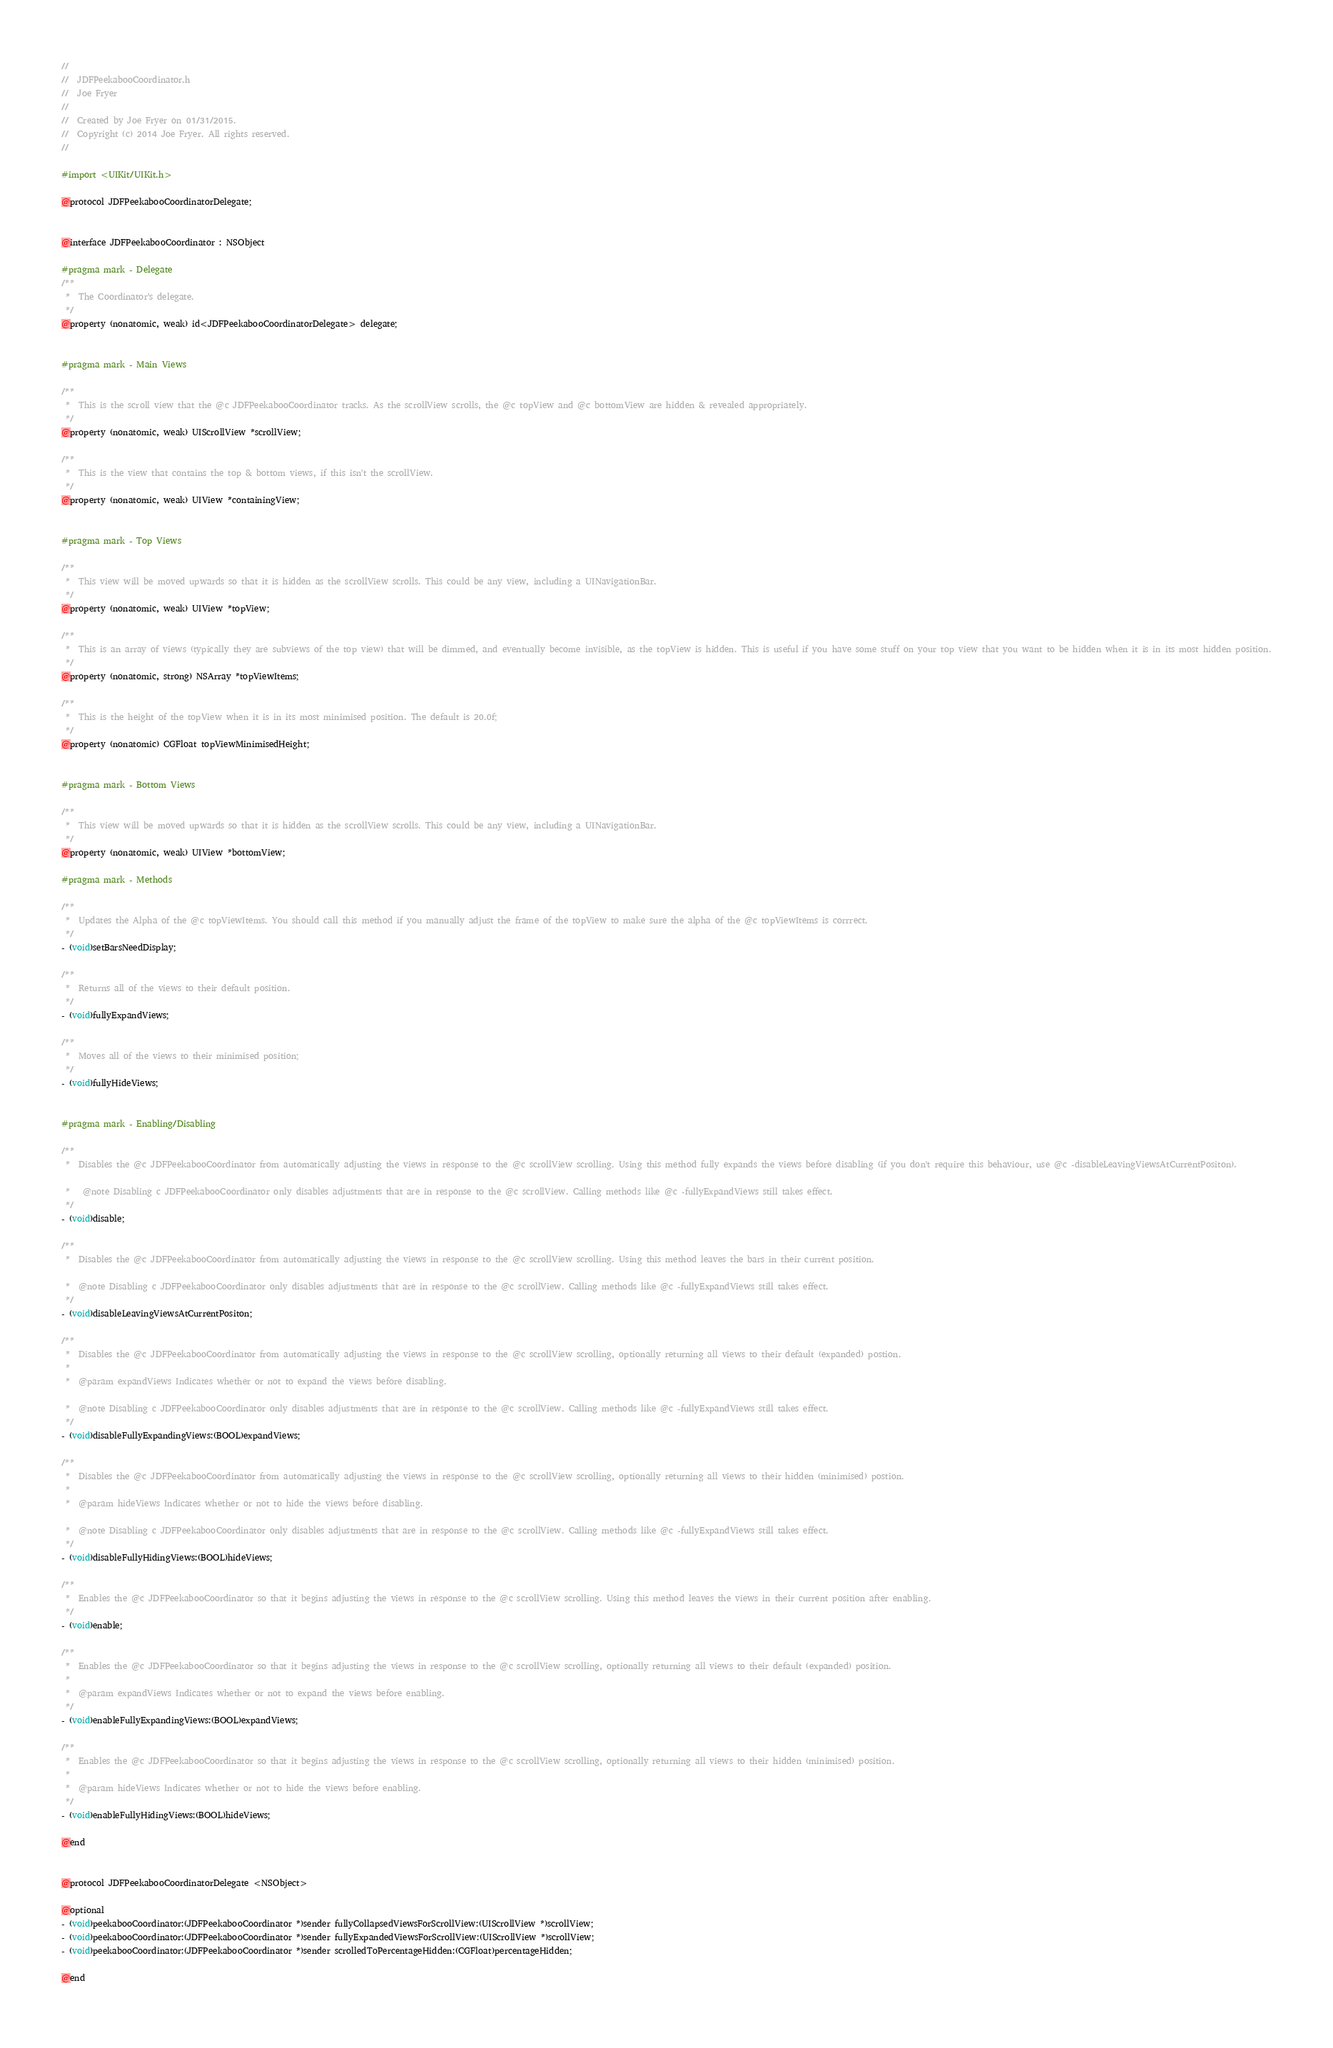Convert code to text. <code><loc_0><loc_0><loc_500><loc_500><_C_>//
//  JDFPeekabooCoordinator.h
//  Joe Fryer
//
//  Created by Joe Fryer on 01/31/2015.
//  Copyright (c) 2014 Joe Fryer. All rights reserved.
//

#import <UIKit/UIKit.h>

@protocol JDFPeekabooCoordinatorDelegate;


@interface JDFPeekabooCoordinator : NSObject

#pragma mark - Delegate
/**
 *  The Coordinator's delegate.
 */
@property (nonatomic, weak) id<JDFPeekabooCoordinatorDelegate> delegate;


#pragma mark - Main Views

/**
 *  This is the scroll view that the @c JDFPeekabooCoordinator tracks. As the scrollView scrolls, the @c topView and @c bottomView are hidden & revealed appropriately.
 */
@property (nonatomic, weak) UIScrollView *scrollView;

/**
 *  This is the view that contains the top & bottom views, if this isn't the scrollView.
 */
@property (nonatomic, weak) UIView *containingView;


#pragma mark - Top Views

/**
 *  This view will be moved upwards so that it is hidden as the scrollView scrolls. This could be any view, including a UINavigationBar.
 */
@property (nonatomic, weak) UIView *topView;

/**
 *  This is an array of views (typically they are subviews of the top view) that will be dimmed, and eventually become invisible, as the topView is hidden. This is useful if you have some stuff on your top view that you want to be hidden when it is in its most hidden position.
 */
@property (nonatomic, strong) NSArray *topViewItems;

/**
 *  This is the height of the topView when it is in its most minimised position. The default is 20.0f;
 */
@property (nonatomic) CGFloat topViewMinimisedHeight;


#pragma mark - Bottom Views

/**
 *  This view will be moved upwards so that it is hidden as the scrollView scrolls. This could be any view, including a UINavigationBar.
 */
@property (nonatomic, weak) UIView *bottomView;

#pragma mark - Methods

/**
 *  Updates the Alpha of the @c topViewItems. You should call this method if you manually adjust the frame of the topView to make sure the alpha of the @c topViewItems is corrrect.
 */
- (void)setBarsNeedDisplay;

/**
 *  Returns all of the views to their default position.
 */
- (void)fullyExpandViews;

/**
 *  Moves all of the views to their minimised position;
 */
- (void)fullyHideViews;


#pragma mark - Enabling/Disabling

/**
 *  Disables the @c JDFPeekabooCoordinator from automatically adjusting the views in response to the @c scrollView scrolling. Using this method fully expands the views before disabling (if you don't require this behaviour, use @c -disableLeavingViewsAtCurrentPositon).
 
 *   @note Disabling c JDFPeekabooCoordinator only disables adjustments that are in response to the @c scrollView. Calling methods like @c -fullyExpandViews still takes effect.
 */
- (void)disable;

/**
 *  Disables the @c JDFPeekabooCoordinator from automatically adjusting the views in response to the @c scrollView scrolling. Using this method leaves the bars in their current position.
 
 *  @note Disabling c JDFPeekabooCoordinator only disables adjustments that are in response to the @c scrollView. Calling methods like @c -fullyExpandViews still takes effect.
 */
- (void)disableLeavingViewsAtCurrentPositon;

/**
 *  Disables the @c JDFPeekabooCoordinator from automatically adjusting the views in response to the @c scrollView scrolling, optionally returning all views to their default (expanded) postion.
 *
 *  @param expandViews Indicates whether or not to expand the views before disabling.
 
 *  @note Disabling c JDFPeekabooCoordinator only disables adjustments that are in response to the @c scrollView. Calling methods like @c -fullyExpandViews still takes effect.
 */
- (void)disableFullyExpandingViews:(BOOL)expandViews;

/**
 *  Disables the @c JDFPeekabooCoordinator from automatically adjusting the views in response to the @c scrollView scrolling, optionally returning all views to their hidden (minimised) postion.
 *
 *  @param hideViews Indicates whether or not to hide the views before disabling.
 
 *  @note Disabling c JDFPeekabooCoordinator only disables adjustments that are in response to the @c scrollView. Calling methods like @c -fullyExpandViews still takes effect.
 */
- (void)disableFullyHidingViews:(BOOL)hideViews;

/**
 *  Enables the @c JDFPeekabooCoordinator so that it begins adjusting the views in response to the @c scrollView scrolling. Using this method leaves the views in their current position after enabling.
 */
- (void)enable;

/**
 *  Enables the @c JDFPeekabooCoordinator so that it begins adjusting the views in response to the @c scrollView scrolling, optionally returning all views to their default (expanded) position.
 *
 *  @param expandViews Indicates whether or not to expand the views before enabling.
 */
- (void)enableFullyExpandingViews:(BOOL)expandViews;

/**
 *  Enables the @c JDFPeekabooCoordinator so that it begins adjusting the views in response to the @c scrollView scrolling, optionally returning all views to their hidden (minimised) position.
 *
 *  @param hideViews Indicates whether or not to hide the views before enabling.
 */
- (void)enableFullyHidingViews:(BOOL)hideViews;

@end


@protocol JDFPeekabooCoordinatorDelegate <NSObject>

@optional
- (void)peekabooCoordinator:(JDFPeekabooCoordinator *)sender fullyCollapsedViewsForScrollView:(UIScrollView *)scrollView;
- (void)peekabooCoordinator:(JDFPeekabooCoordinator *)sender fullyExpandedViewsForScrollView:(UIScrollView *)scrollView;
- (void)peekabooCoordinator:(JDFPeekabooCoordinator *)sender scrolledToPercentageHidden:(CGFloat)percentageHidden;

@end
</code> 